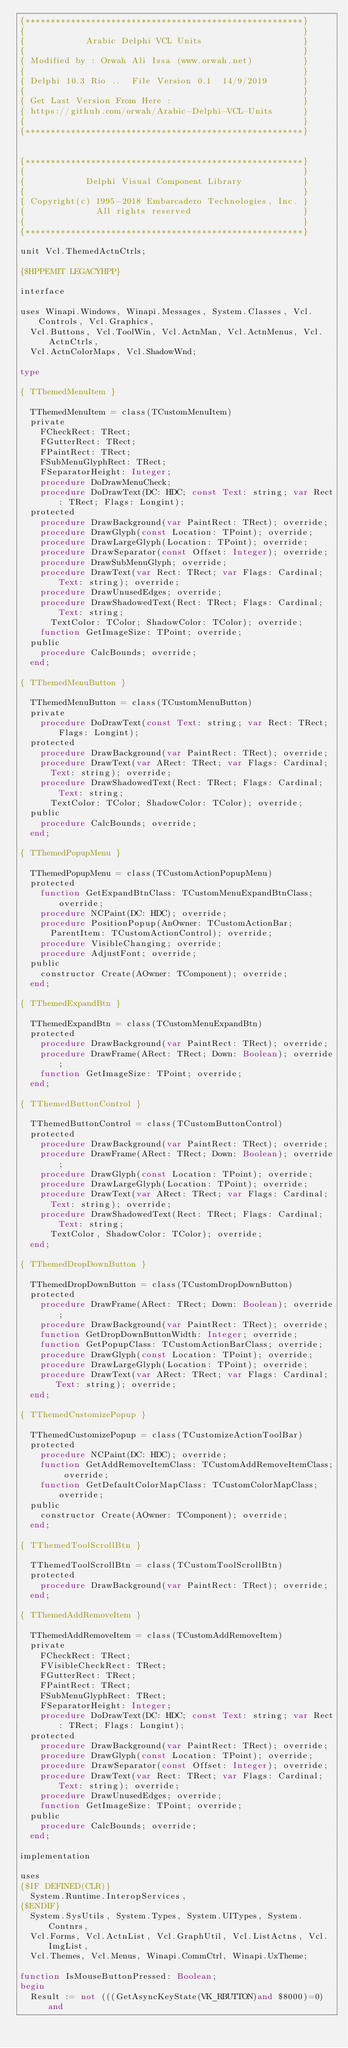<code> <loc_0><loc_0><loc_500><loc_500><_Pascal_>{*******************************************************}
{                                                       }
{            Arabic Delphi VCL Units                    }
{                                                       }
{ Modified by : Orwah Ali Issa (www.orwah.net)          }
{                                                       }
{ Delphi 10.3 Rio ..  File Version 0.1  14/9/2019       }
{                                                       }
{ Get Last Version From Here :                          }
{ https://github.com/orwah/Arabic-Delphi-VCL-Units      }
{                                                       }
{*******************************************************}


{*******************************************************}
{                                                       }
{            Delphi Visual Component Library            }
{                                                       }
{ Copyright(c) 1995-2018 Embarcadero Technologies, Inc. }
{              All rights reserved                      }
{                                                       }
{*******************************************************}

unit Vcl.ThemedActnCtrls;

{$HPPEMIT LEGACYHPP}

interface

uses Winapi.Windows, Winapi.Messages, System.Classes, Vcl.Controls, Vcl.Graphics,
  Vcl.Buttons, Vcl.ToolWin, Vcl.ActnMan, Vcl.ActnMenus, Vcl.ActnCtrls,
  Vcl.ActnColorMaps, Vcl.ShadowWnd;

type

{ TThemedMenuItem }

  TThemedMenuItem = class(TCustomMenuItem)
  private
    FCheckRect: TRect;
    FGutterRect: TRect;
    FPaintRect: TRect;
    FSubMenuGlyphRect: TRect;
    FSeparatorHeight: Integer;
    procedure DoDrawMenuCheck;
    procedure DoDrawText(DC: HDC; const Text: string; var Rect: TRect; Flags: Longint);
  protected
    procedure DrawBackground(var PaintRect: TRect); override;
    procedure DrawGlyph(const Location: TPoint); override;
    procedure DrawLargeGlyph(Location: TPoint); override;
    procedure DrawSeparator(const Offset: Integer); override;
    procedure DrawSubMenuGlyph; override;
    procedure DrawText(var Rect: TRect; var Flags: Cardinal; Text: string); override;
    procedure DrawUnusedEdges; override;
    procedure DrawShadowedText(Rect: TRect; Flags: Cardinal; Text: string;
      TextColor: TColor; ShadowColor: TColor); override;
    function GetImageSize: TPoint; override;
  public
    procedure CalcBounds; override;
  end;

{ TThemedMenuButton }

  TThemedMenuButton = class(TCustomMenuButton)
  private
    procedure DoDrawText(const Text: string; var Rect: TRect; Flags: Longint);
  protected
    procedure DrawBackground(var PaintRect: TRect); override;
    procedure DrawText(var ARect: TRect; var Flags: Cardinal;
      Text: string); override;
    procedure DrawShadowedText(Rect: TRect; Flags: Cardinal; Text: string;
      TextColor: TColor; ShadowColor: TColor); override;
  public
    procedure CalcBounds; override;
  end;

{ TThemedPopupMenu }

  TThemedPopupMenu = class(TCustomActionPopupMenu)
  protected
    function GetExpandBtnClass: TCustomMenuExpandBtnClass; override;
    procedure NCPaint(DC: HDC); override;
    procedure PositionPopup(AnOwner: TCustomActionBar;
      ParentItem: TCustomActionControl); override;
    procedure VisibleChanging; override;
    procedure AdjustFont; override;
  public
    constructor Create(AOwner: TComponent); override;
  end;

{ TThemedExpandBtn }

  TThemedExpandBtn = class(TCustomMenuExpandBtn)
  protected
    procedure DrawBackground(var PaintRect: TRect); override;
    procedure DrawFrame(ARect: TRect; Down: Boolean); override;
    function GetImageSize: TPoint; override;
  end;

{ TThemedButtonControl }

  TThemedButtonControl = class(TCustomButtonControl)
  protected
    procedure DrawBackground(var PaintRect: TRect); override;
    procedure DrawFrame(ARect: TRect; Down: Boolean); override;
    procedure DrawGlyph(const Location: TPoint); override;
    procedure DrawLargeGlyph(Location: TPoint); override;
    procedure DrawText(var ARect: TRect; var Flags: Cardinal;
      Text: string); override;
    procedure DrawShadowedText(Rect: TRect; Flags: Cardinal; Text: string;
      TextColor, ShadowColor: TColor); override;
  end;

{ TThemedDropDownButton }

  TThemedDropDownButton = class(TCustomDropDownButton)
  protected
    procedure DrawFrame(ARect: TRect; Down: Boolean); override;
    procedure DrawBackground(var PaintRect: TRect); override;
    function GetDropDownButtonWidth: Integer; override;
    function GetPopupClass: TCustomActionBarClass; override;
    procedure DrawGlyph(const Location: TPoint); override;
    procedure DrawLargeGlyph(Location: TPoint); override;
    procedure DrawText(var ARect: TRect; var Flags: Cardinal;
       Text: string); override;
  end;

{ TThemedCustomizePopup }

  TThemedCustomizePopup = class(TCustomizeActionToolBar)
  protected
    procedure NCPaint(DC: HDC); override;
    function GetAddRemoveItemClass: TCustomAddRemoveItemClass; override;
    function GetDefaultColorMapClass: TCustomColorMapClass; override;
  public
    constructor Create(AOwner: TComponent); override;
  end;

{ TThemedToolScrollBtn }

  TThemedToolScrollBtn = class(TCustomToolScrollBtn)
  protected
    procedure DrawBackground(var PaintRect: TRect); override;
  end;

{ TThemedAddRemoveItem }

  TThemedAddRemoveItem = class(TCustomAddRemoveItem)
  private
    FCheckRect: TRect;
    FVisibleCheckRect: TRect;
    FGutterRect: TRect;
    FPaintRect: TRect;
    FSubMenuGlyphRect: TRect;
    FSeparatorHeight: Integer;
    procedure DoDrawText(DC: HDC; const Text: string; var Rect: TRect; Flags: Longint);
  protected
    procedure DrawBackground(var PaintRect: TRect); override;
    procedure DrawGlyph(const Location: TPoint); override;
    procedure DrawSeparator(const Offset: Integer); override;
    procedure DrawText(var Rect: TRect; var Flags: Cardinal; Text: string); override;
    procedure DrawUnusedEdges; override;
    function GetImageSize: TPoint; override;
  public
    procedure CalcBounds; override;
  end;

implementation

uses
{$IF DEFINED(CLR)}
  System.Runtime.InteropServices,
{$ENDIF}
  System.SysUtils, System.Types, System.UITypes, System.Contnrs, 
  Vcl.Forms, Vcl.ActnList, Vcl.GraphUtil, Vcl.ListActns, Vcl.ImgList,
  Vcl.Themes, Vcl.Menus, Winapi.CommCtrl, Winapi.UxTheme;

function IsMouseButtonPressed: Boolean;
begin
  Result := not (((GetAsyncKeyState(VK_RBUTTON)and $8000)=0) and</code> 